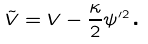Convert formula to latex. <formula><loc_0><loc_0><loc_500><loc_500>\tilde { V } = V - \frac { \kappa } { 2 } \psi ^ { \prime 2 } \text {.}</formula> 